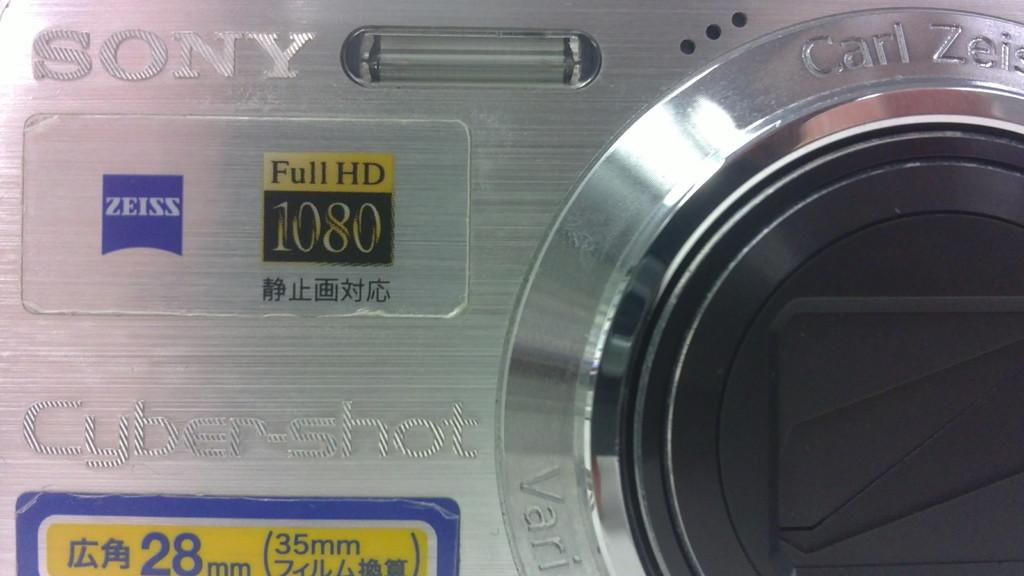What is the main subject of the image? The main subject of the image is a camera. Where is the camera located in the image? The camera is in the center of the image. What brand and model of camera is shown in the image? The camera is a "Sony Cyber Shot" model. What type of locket is hanging from the camera in the image? There is no locket present in the image; it only features a camera. 